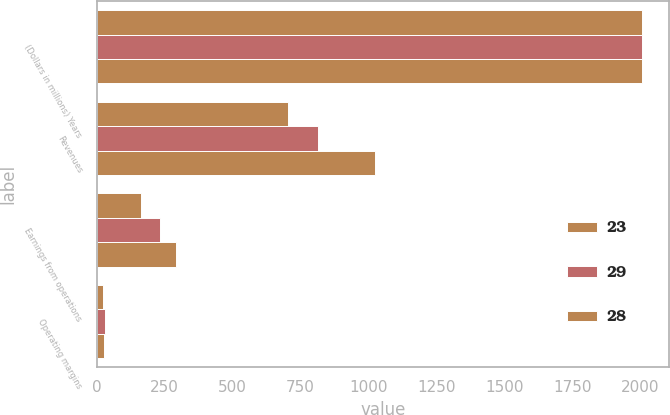Convert chart. <chart><loc_0><loc_0><loc_500><loc_500><stacked_bar_chart><ecel><fcel>(Dollars in millions) Years<fcel>Revenues<fcel>Earnings from operations<fcel>Operating margins<nl><fcel>23<fcel>2008<fcel>703<fcel>162<fcel>23<nl><fcel>29<fcel>2007<fcel>815<fcel>234<fcel>29<nl><fcel>28<fcel>2006<fcel>1025<fcel>291<fcel>28<nl></chart> 